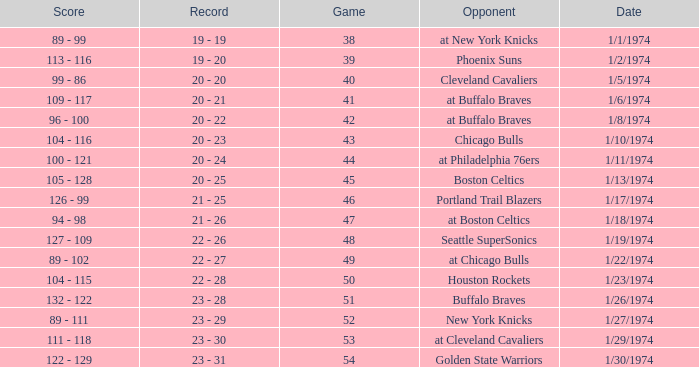What was the score on 1/10/1974? 104 - 116. 